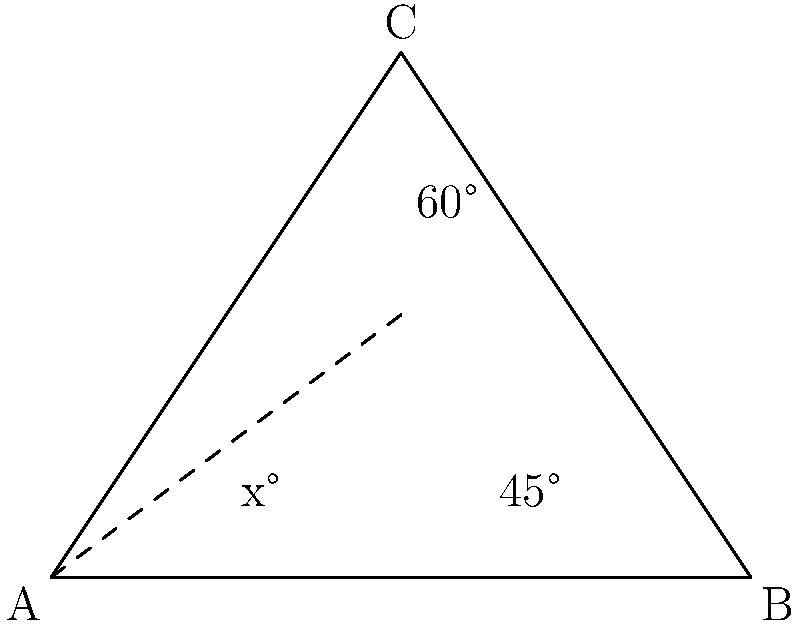In your latest origami project, you're creating a paper crane with precise wing angles. The triangular wing section ABC is shown above, where angle BAC is denoted as $x°$. Given that angle ABC is $45°$ and angle BCA is $60°$, determine the value of $x$. To solve this problem, let's follow these steps:

1) In any triangle, the sum of all interior angles is always $180°$. We can express this as:

   $x° + 45° + 60° = 180°$

2) Now, let's isolate $x$ by subtracting the known angles from both sides:

   $x° = 180° - 45° - 60°$

3) Simplify the right side of the equation:

   $x° = 180° - 105° = 75°$

Therefore, the value of $x$ is $75°$.

This angle measurement is crucial for achieving the precise fold needed in the paper crane's wing structure.
Answer: $75°$ 